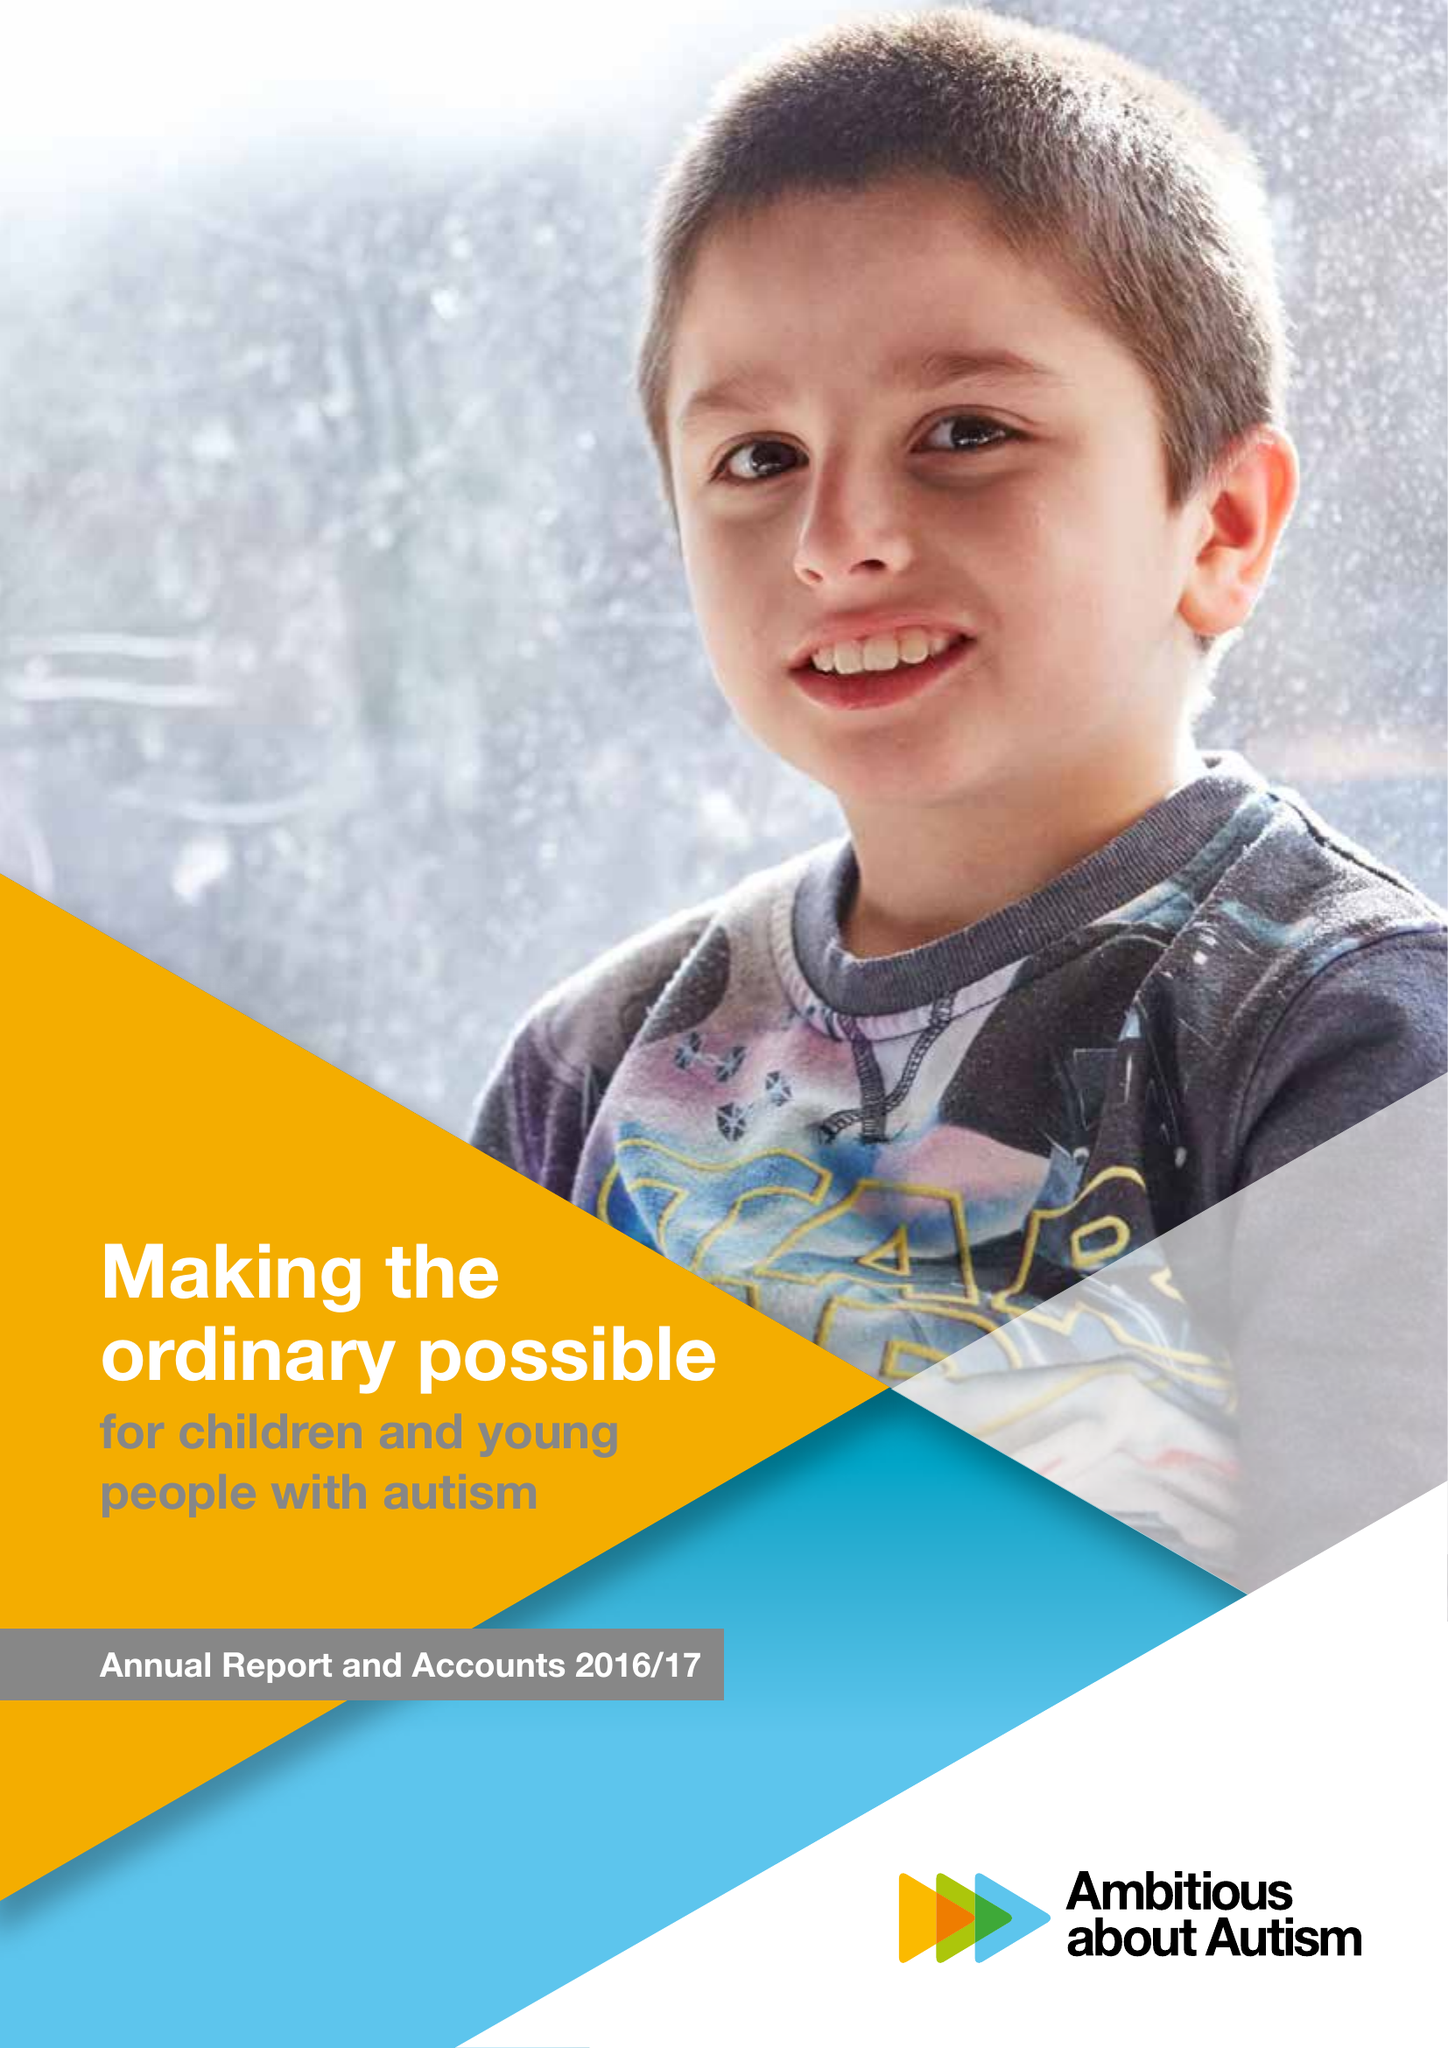What is the value for the address__postcode?
Answer the question using a single word or phrase. N10 3JA 